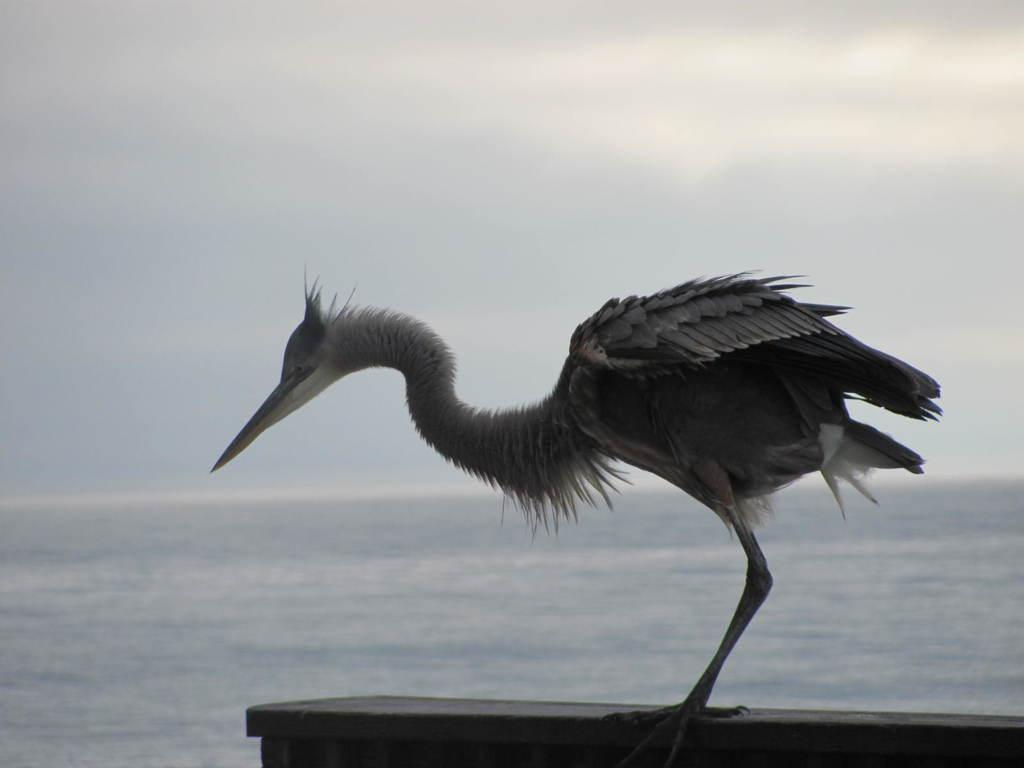What is the main subject of the image? There is a bird standing on a wall in the image. What can be seen in the background of the image? There is a water body in the background of the image. How would you describe the sky in the image? The sky is clear in the image. What reason does the tiger have for being present in the image? There is no tiger present in the image. How does the bird interact with the earth in the image? The bird is standing on a wall in the image, so it is not interacting with the earth directly. 